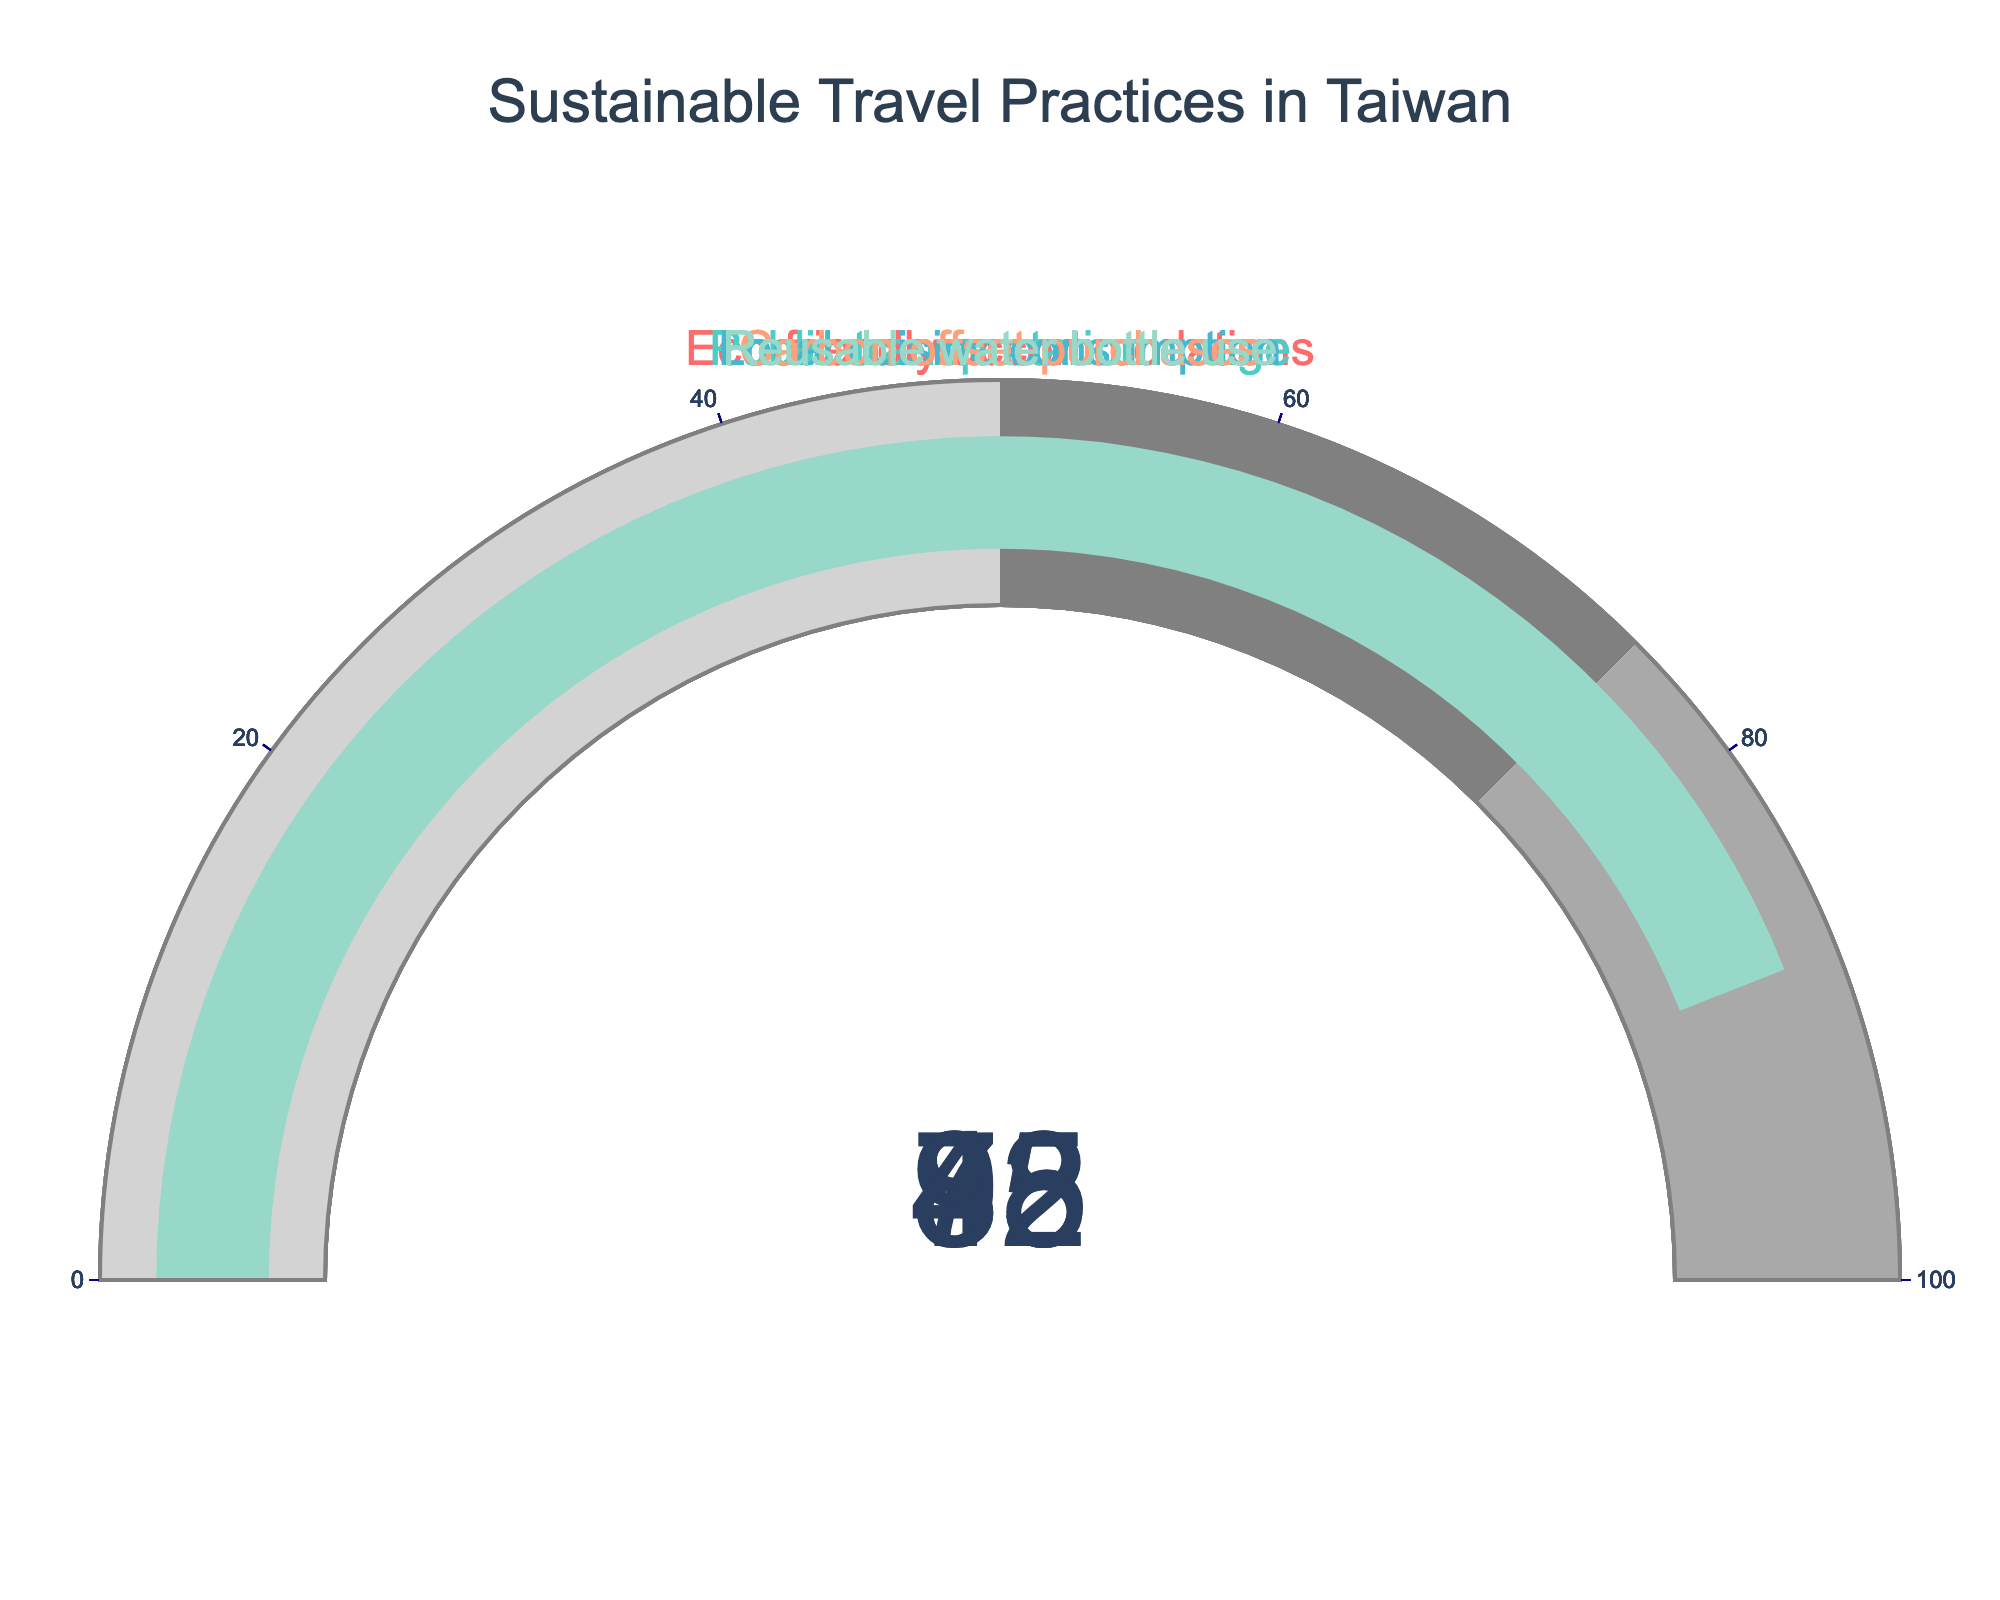What's the percentage of eco-friendly accommodations? The figure's eco-friendly accommodations gauge shows the percentage value directly.
Answer: 72 Which category has the highest percentage? Comparing all the gauge values, local cuisine consumption has the highest percentage.
Answer: Local cuisine consumption What is the difference between reusable water bottle use and carbon offset purchases? Reusable water bottle use is 88% and carbon offset purchases is 45%. The difference is calculated by 88 - 45.
Answer: 43 What is the average percentage of all categories? Add the percentages of all categories: (72 + 85 + 93 + 45 + 88) = 383. Then, divide by the number of categories, which is 5: 383 / 5.
Answer: 76.6 Which category has the lowest percentage and what is it? By examining the gauge values, carbon offset purchases has the lowest percentage.
Answer: Carbon offset purchases, 45 Of the 5 categories, how many have a percentage of 80 or more? Looking at the gauge values, public transportation usage (85), local cuisine consumption (93), and reusable water bottle use (88) are all 80 or more.
Answer: 3 Is the percentage for eco-friendly accommodations above or below 75? The eco-friendly accommodations gauge shows a value of 72, which is below 75.
Answer: Below What is the total percentage when adding public transportation usage and local cuisine consumption? Public transportation usage is 85% and local cuisine consumption is 93%. Adding them gives 85 + 93.
Answer: 178 How much higher is local cuisine consumption compared to eco-friendly accommodations? Local cuisine consumption is at 93% while eco-friendly accommodations is at 72%. Subtracting these gives 93 - 72.
Answer: 21 How many categories have percentages below 50? The only category below 50 is carbon offset purchases at 45%. Therefore, there is just one category below 50.
Answer: 1 